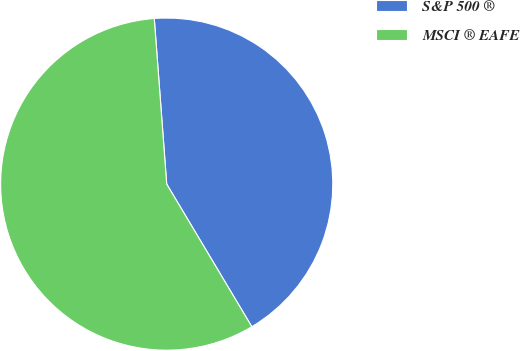<chart> <loc_0><loc_0><loc_500><loc_500><pie_chart><fcel>S&P 500 ®<fcel>MSCI ® EAFE<nl><fcel>42.63%<fcel>57.37%<nl></chart> 